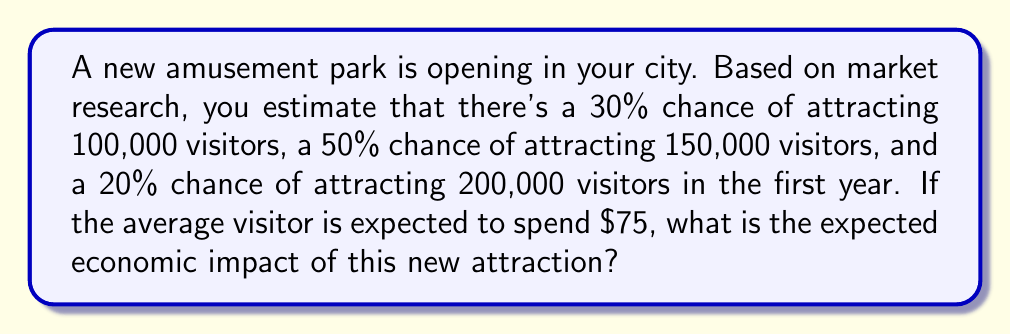Can you answer this question? To solve this problem, we'll use the concept of expected value. Let's break it down step-by-step:

1) First, let's define our variables:
   $p_1 = 0.30$, $v_1 = 100,000$
   $p_2 = 0.50$, $v_2 = 150,000$
   $p_3 = 0.20$, $v_3 = 200,000$
   $s = \$75$ (average spending per visitor)

2) The expected number of visitors is calculated as:
   $E(V) = p_1v_1 + p_2v_2 + p_3v_3$

3) Let's substitute the values:
   $E(V) = 0.30(100,000) + 0.50(150,000) + 0.20(200,000)$

4) Calculate:
   $E(V) = 30,000 + 75,000 + 40,000 = 145,000$ visitors

5) Now, to get the expected economic impact, we multiply the expected number of visitors by the average spending:
   $E(\text{Impact}) = E(V) \times s = 145,000 \times \$75 = \$10,875,000$

Therefore, the expected economic impact of the new attraction is $10,875,000.
Answer: $\$10,875,000$ 